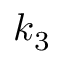Convert formula to latex. <formula><loc_0><loc_0><loc_500><loc_500>k _ { 3 }</formula> 